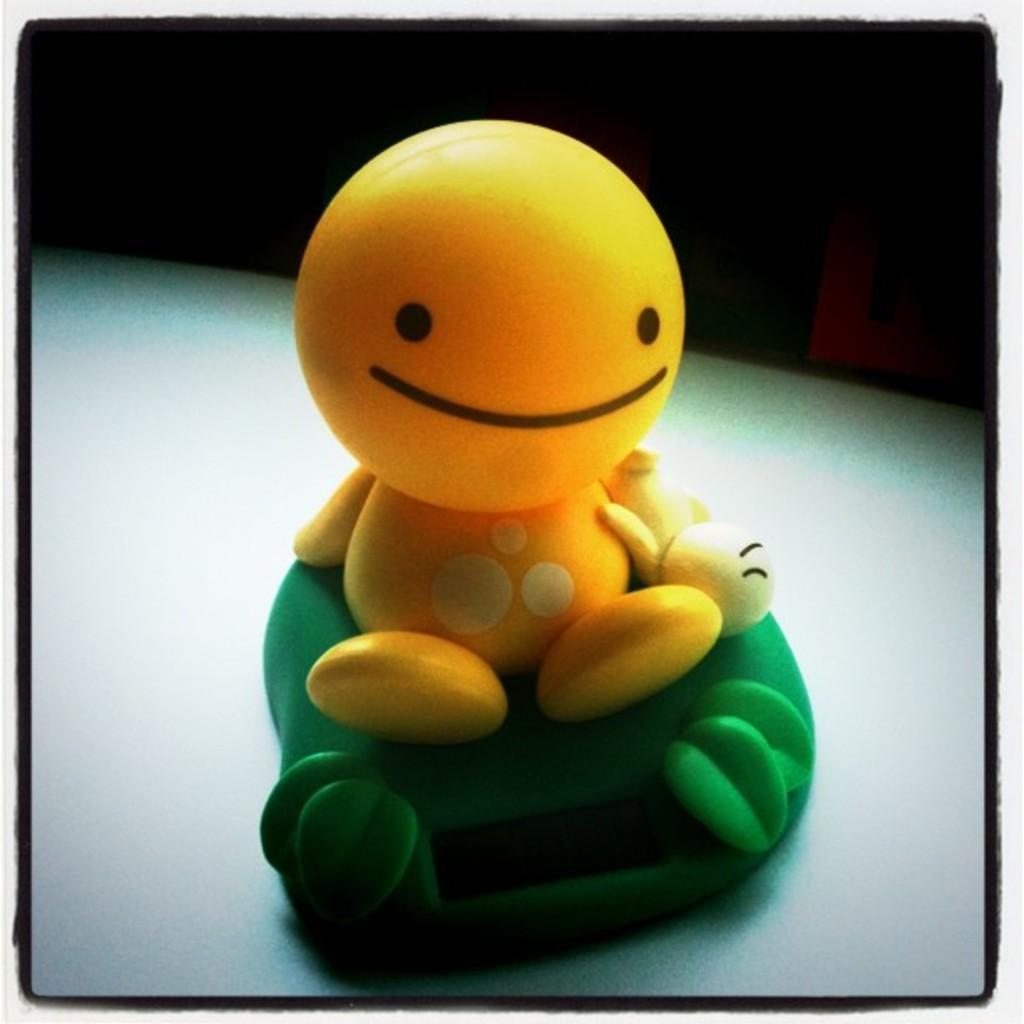Can you describe this image briefly? In this picture I see yellow color toy on a green color thing. 